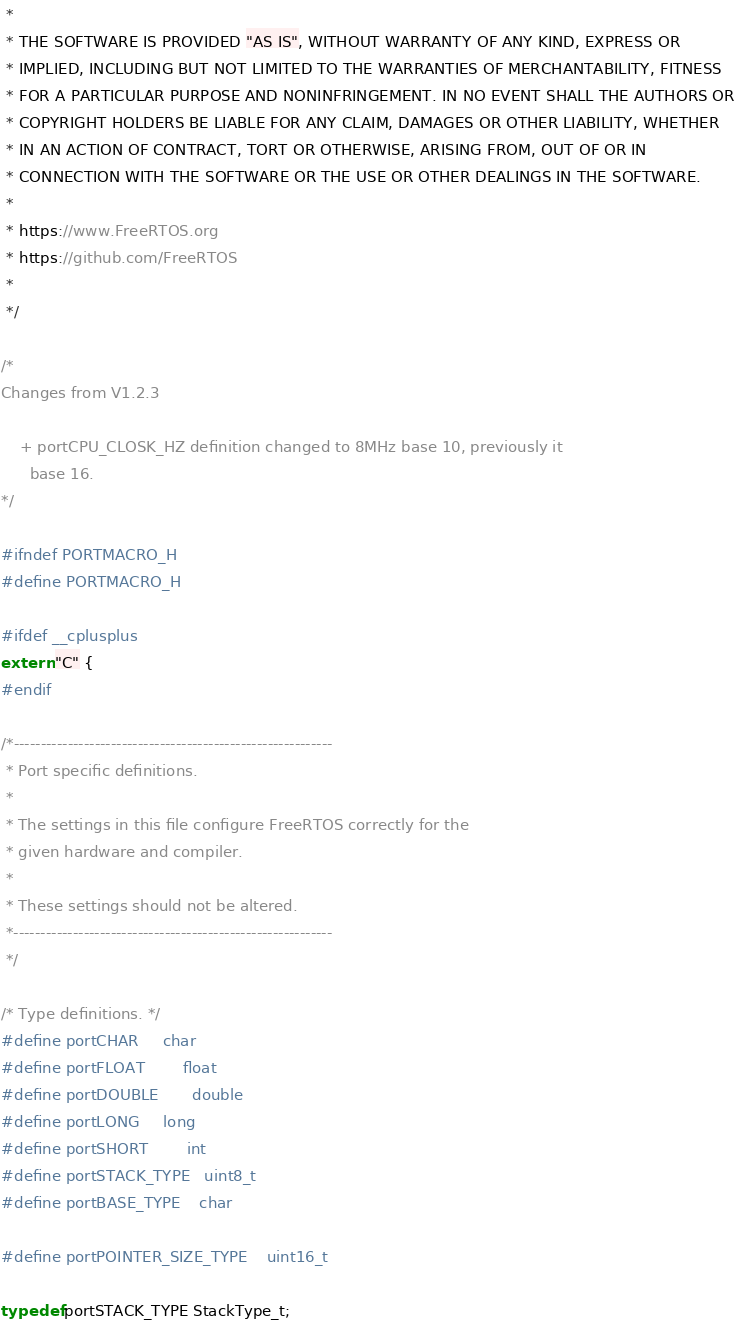Convert code to text. <code><loc_0><loc_0><loc_500><loc_500><_C_> *
 * THE SOFTWARE IS PROVIDED "AS IS", WITHOUT WARRANTY OF ANY KIND, EXPRESS OR
 * IMPLIED, INCLUDING BUT NOT LIMITED TO THE WARRANTIES OF MERCHANTABILITY, FITNESS
 * FOR A PARTICULAR PURPOSE AND NONINFRINGEMENT. IN NO EVENT SHALL THE AUTHORS OR
 * COPYRIGHT HOLDERS BE LIABLE FOR ANY CLAIM, DAMAGES OR OTHER LIABILITY, WHETHER
 * IN AN ACTION OF CONTRACT, TORT OR OTHERWISE, ARISING FROM, OUT OF OR IN
 * CONNECTION WITH THE SOFTWARE OR THE USE OR OTHER DEALINGS IN THE SOFTWARE.
 *
 * https://www.FreeRTOS.org
 * https://github.com/FreeRTOS
 *
 */

/*
Changes from V1.2.3

	+ portCPU_CLOSK_HZ definition changed to 8MHz base 10, previously it
	  base 16.
*/

#ifndef PORTMACRO_H
#define PORTMACRO_H

#ifdef __cplusplus
extern "C" {
#endif

/*-----------------------------------------------------------
 * Port specific definitions.
 *
 * The settings in this file configure FreeRTOS correctly for the
 * given hardware and compiler.
 *
 * These settings should not be altered.
 *-----------------------------------------------------------
 */

/* Type definitions. */
#define portCHAR		char
#define portFLOAT		float
#define portDOUBLE		double
#define portLONG		long
#define portSHORT		int
#define portSTACK_TYPE	uint8_t
#define portBASE_TYPE	char

#define portPOINTER_SIZE_TYPE    uint16_t

typedef portSTACK_TYPE StackType_t;</code> 